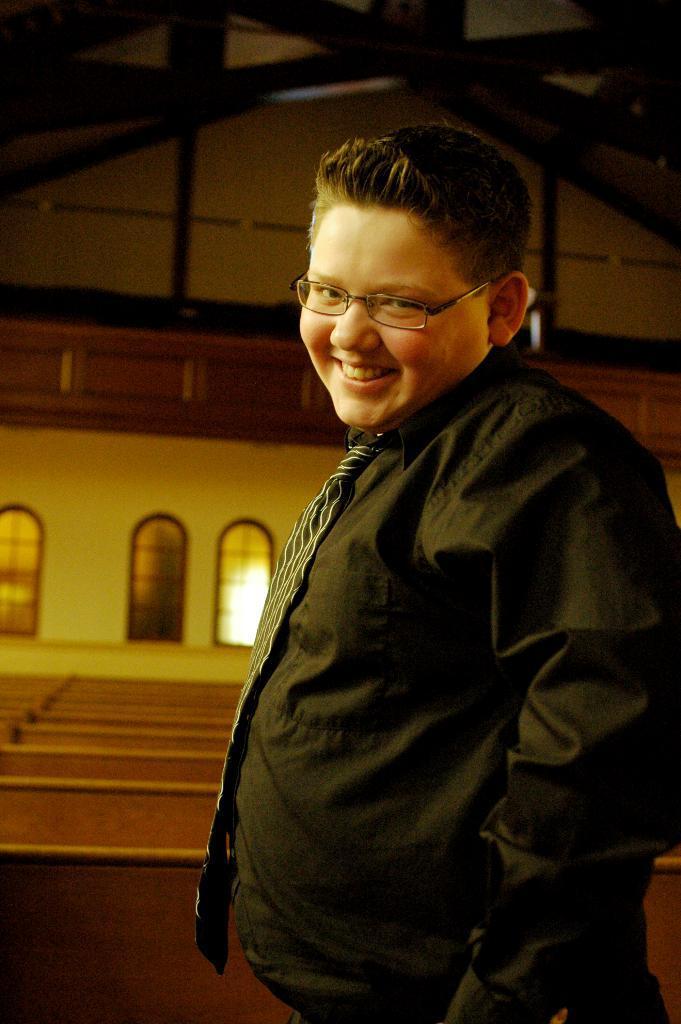Can you describe this image briefly? In this image we can see a person standing and smiling. In the background there are benches and windows. 